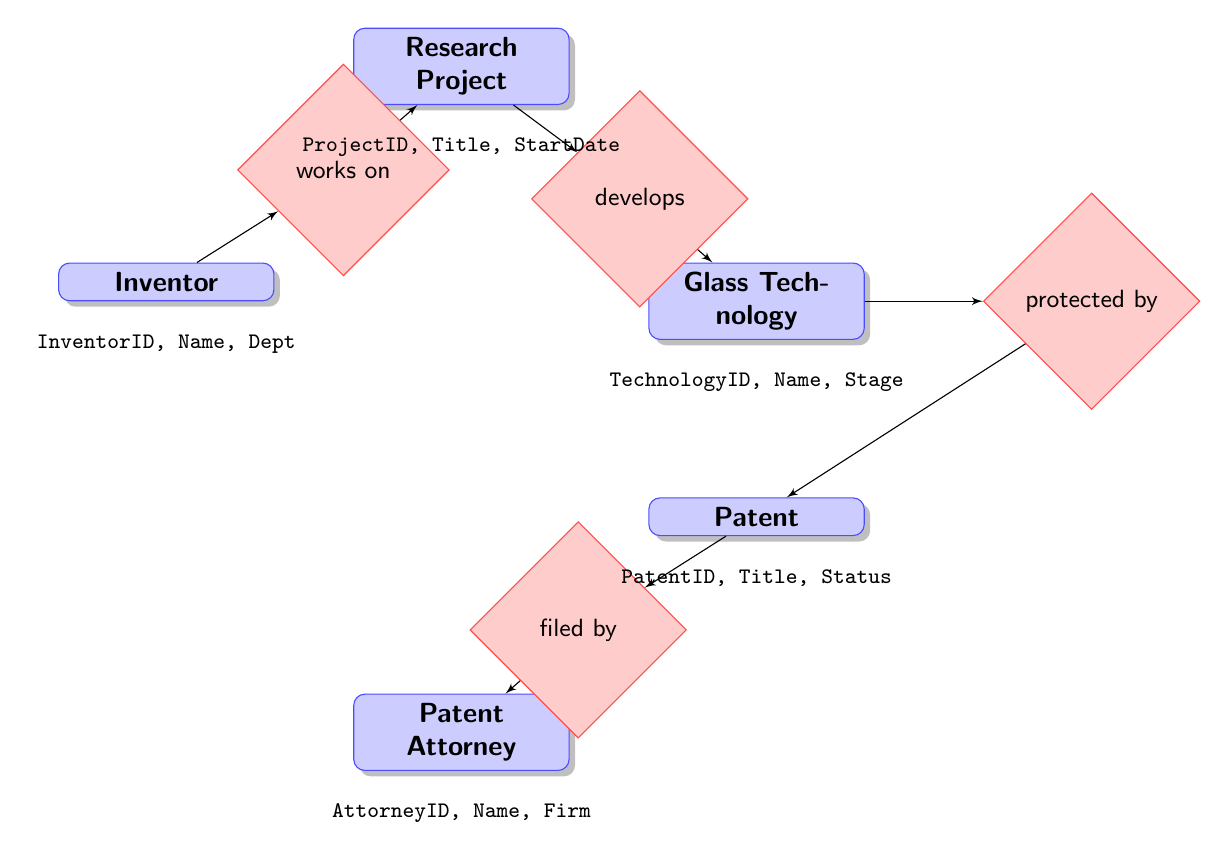What entities are included in the diagram? The entities are listed directly within the diagram: Research Project, Inventor, Glass Technology, Patent, and Patent Attorney. Therefore, we can simply enumerate them based on their presence in the diagram.
Answer: Research Project, Inventor, Glass Technology, Patent, Patent Attorney How many relationships are displayed in the diagram? The relationships are indicated by diamonds within the diagram. By counting each relationship, we find four distinct relationships: works on, develops, protected by, and filed by. This leads us to the conclusion that there are a total of four relationships.
Answer: Four Which entity is responsible for filing a patent? The relationship labeled "filed by" connects the Patent entity to the Patent Attorney entity. This indicates that the Patent Attorney is responsible for filing the patent. Thus, we can accurately identify the responsible entity.
Answer: Patent Attorney What is the relationship between Inventor and Research Project? The relationship is denoted as "works on." This indicates that there is a direct action or connection where an Inventor engages with or contributes to a Research Project. This relationship clarifies the involvement of the Inventor in the Research Project.
Answer: works on How is the Glass Technology related to the Patent? The relationship is represented as "protected by." This shows that a specific Glass Technology is legally protected through a Patent, indicating that the Patent serves as a legal safeguard for the innovations within that Glass Technology.
Answer: protected by Which entity has attributes concerning 'FilingDate'? The FilingDate attribute is listed under the Patent entity. By checking the attributes of each entity in the diagram, we can clearly see that FilingDate specifically belongs to the Patent entity.
Answer: Patent What is the stage of development for a Glass Technology? The Glass Technology entity includes the attribute labeled 'DevelopmentStage.' This indicates that each instance of Glass Technology can have a defined stage of development, which is crucial for understanding its progress in the innovation pipeline.
Answer: DevelopmentStage How does a Research Project relate to Glass Technology? The relationship "develops" connects the Research Project to the Glass Technology. This indicates that there is an active process or initiative where research is focused on developing specific Glass Technology through the Research Project.
Answer: develops What is the primary ID associated with Inventor? The Inventor entity includes the attribute InventorID. This denotes that every inventor in the system is uniquely identified by this ID, crucial for tracking and managing inventor contributions.
Answer: InventorID 